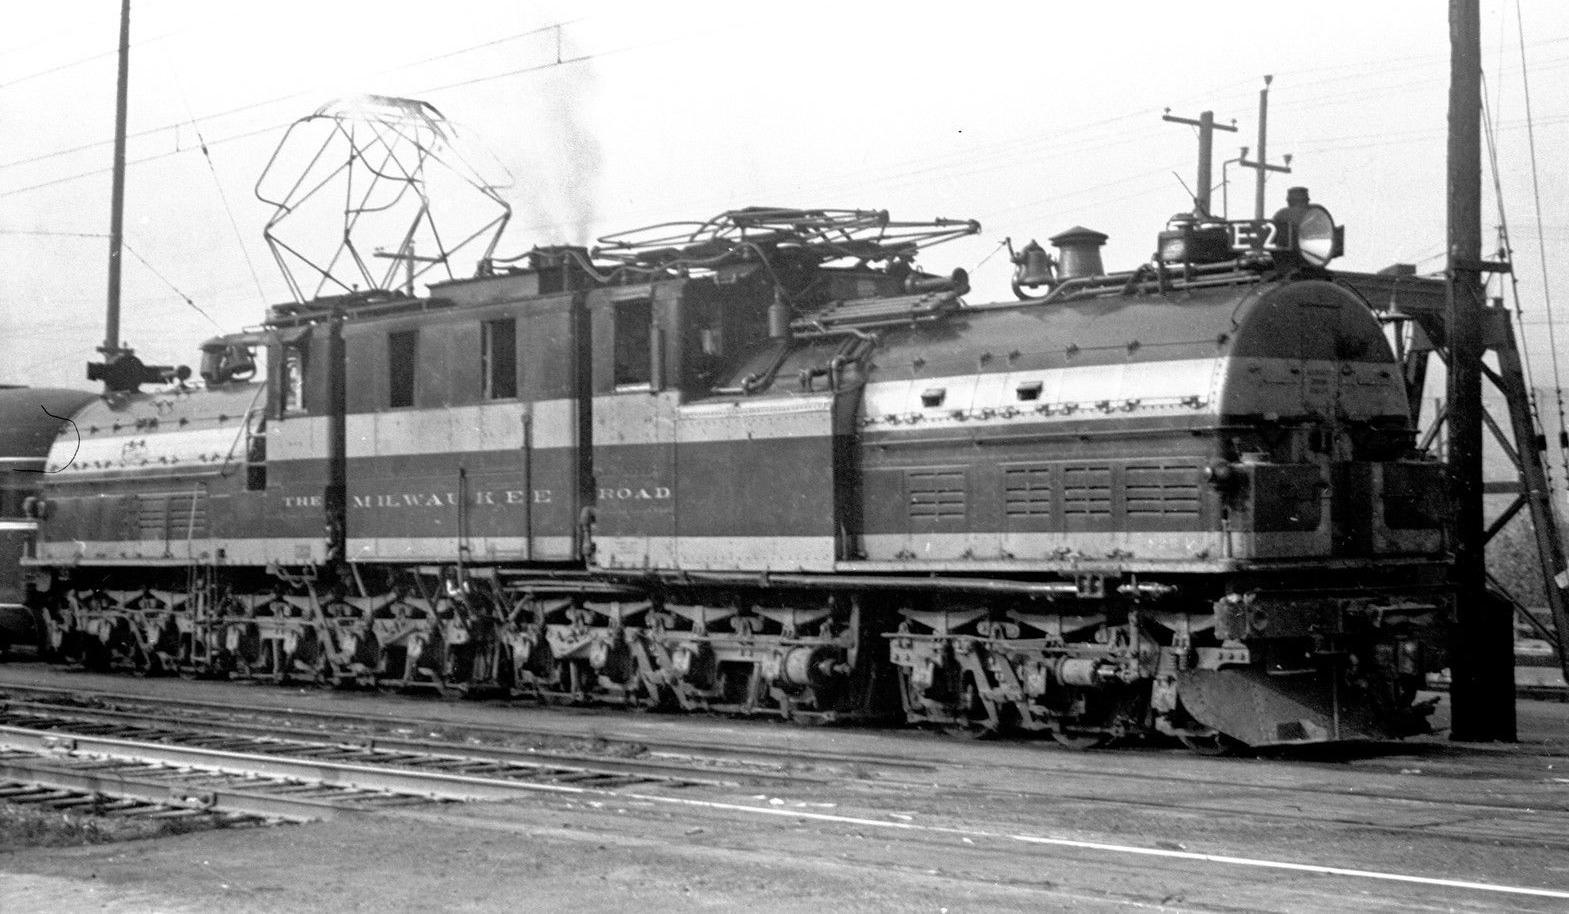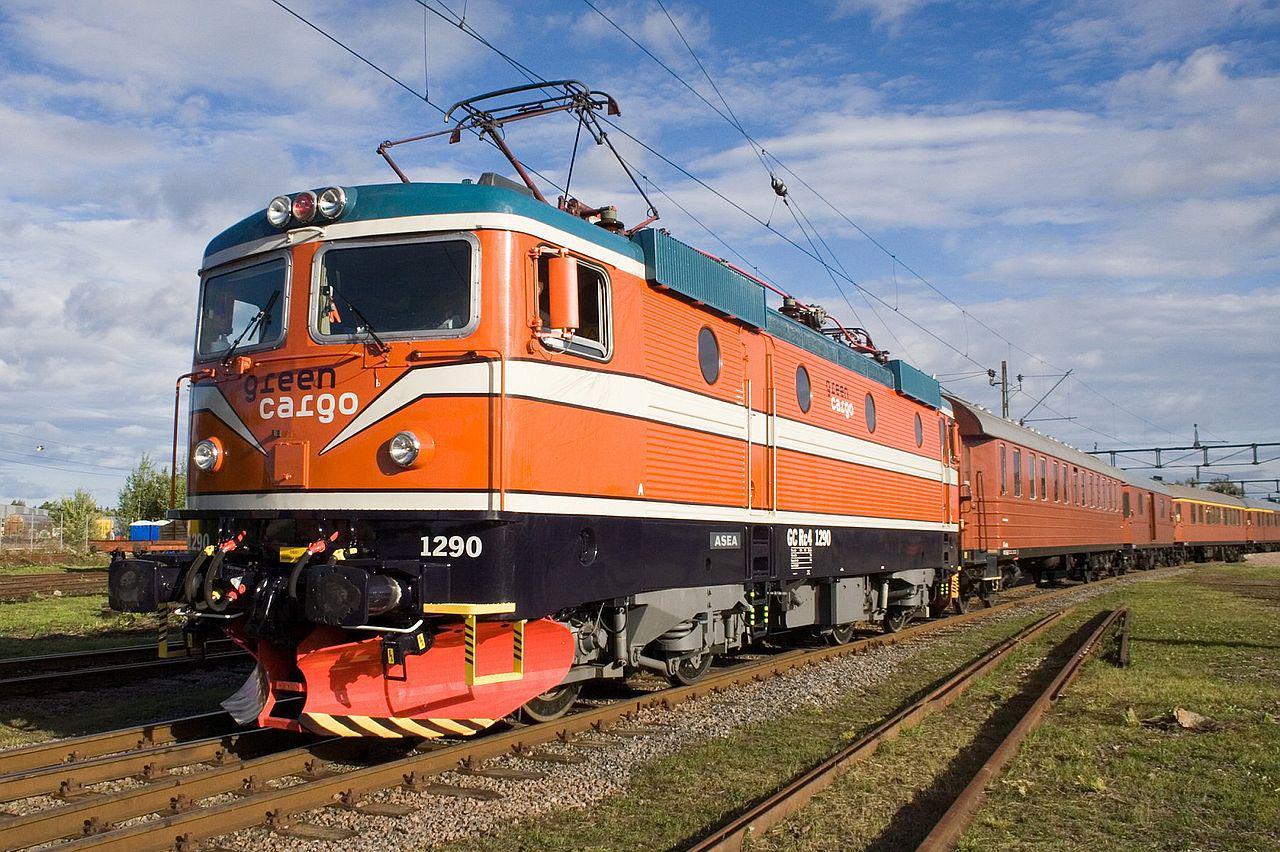The first image is the image on the left, the second image is the image on the right. Analyze the images presented: Is the assertion "Two trains are angled in different directions." valid? Answer yes or no. Yes. 